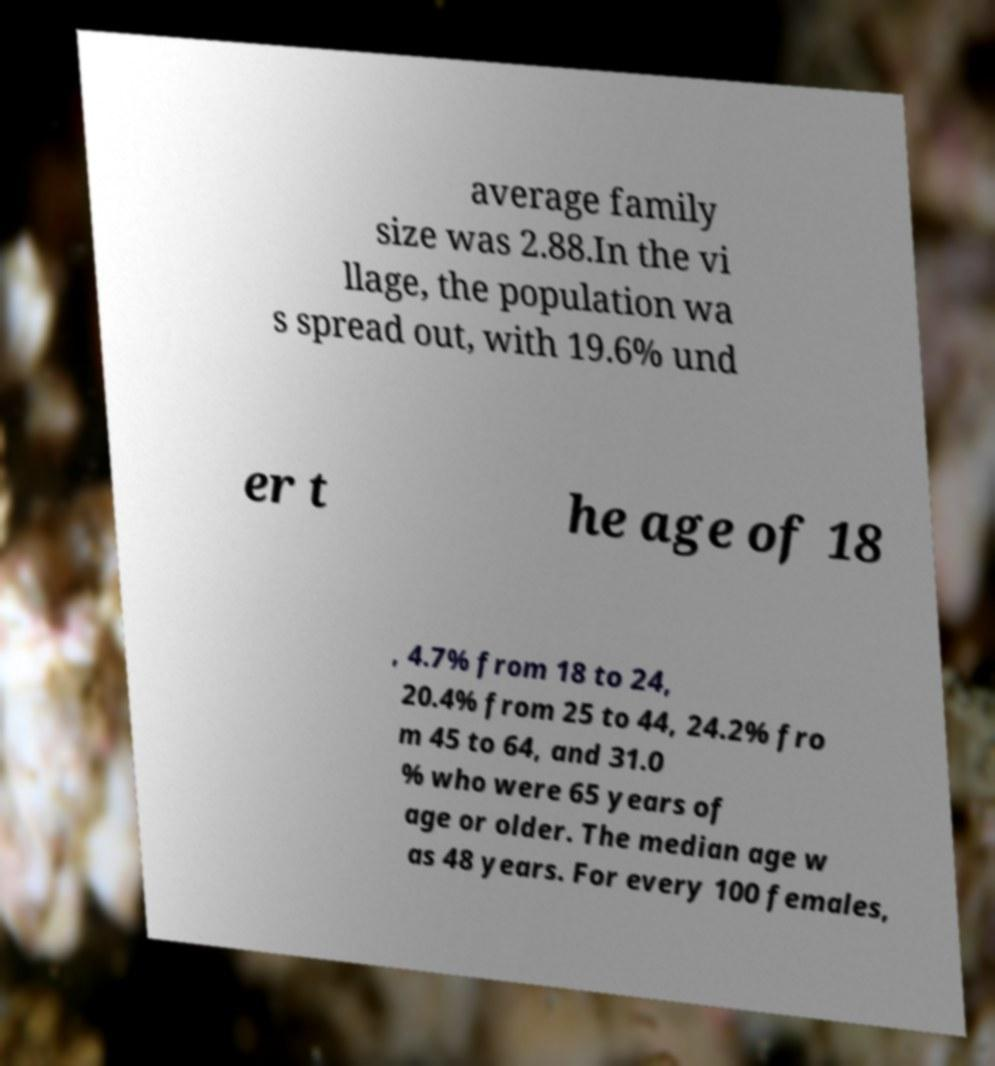I need the written content from this picture converted into text. Can you do that? average family size was 2.88.In the vi llage, the population wa s spread out, with 19.6% und er t he age of 18 , 4.7% from 18 to 24, 20.4% from 25 to 44, 24.2% fro m 45 to 64, and 31.0 % who were 65 years of age or older. The median age w as 48 years. For every 100 females, 